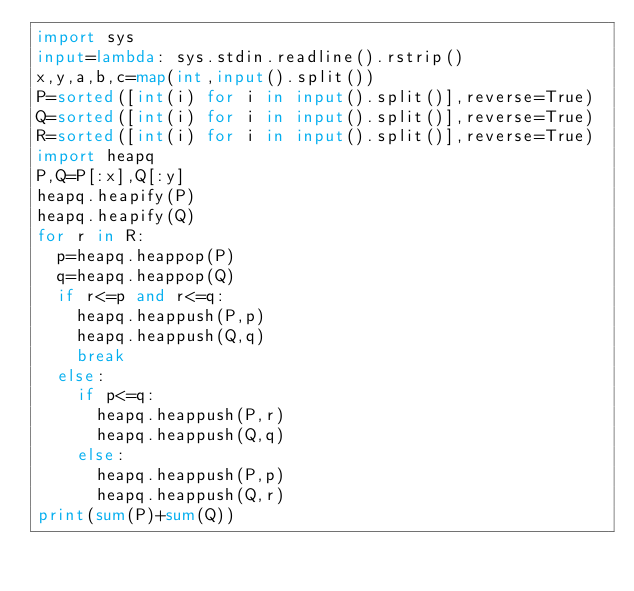<code> <loc_0><loc_0><loc_500><loc_500><_Python_>import sys
input=lambda: sys.stdin.readline().rstrip()
x,y,a,b,c=map(int,input().split())
P=sorted([int(i) for i in input().split()],reverse=True)
Q=sorted([int(i) for i in input().split()],reverse=True)
R=sorted([int(i) for i in input().split()],reverse=True)
import heapq
P,Q=P[:x],Q[:y]
heapq.heapify(P)
heapq.heapify(Q)
for r in R:
  p=heapq.heappop(P)
  q=heapq.heappop(Q)
  if r<=p and r<=q:
    heapq.heappush(P,p)
    heapq.heappush(Q,q)
    break
  else:
    if p<=q:
      heapq.heappush(P,r)
      heapq.heappush(Q,q)
    else:
      heapq.heappush(P,p)
      heapq.heappush(Q,r)
print(sum(P)+sum(Q))
  </code> 